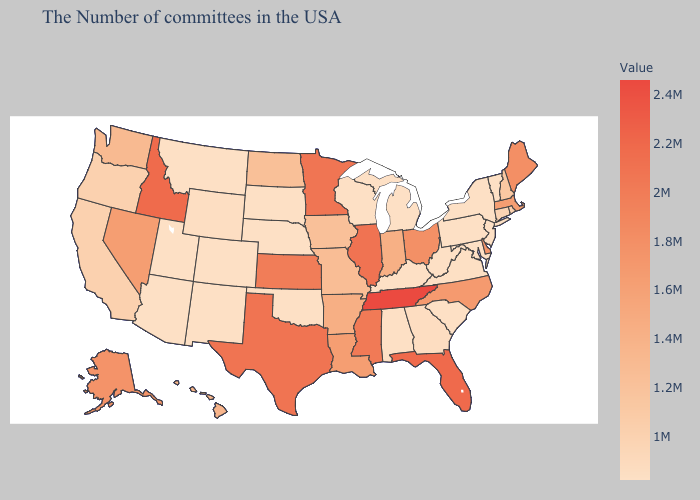Does Pennsylvania have the highest value in the Northeast?
Concise answer only. No. Among the states that border South Dakota , which have the highest value?
Quick response, please. Minnesota. Which states hav the highest value in the South?
Be succinct. Tennessee. Among the states that border Wisconsin , which have the lowest value?
Answer briefly. Michigan. Which states have the lowest value in the West?
Quick response, please. Colorado, New Mexico, Utah, Montana, Arizona. Is the legend a continuous bar?
Quick response, please. Yes. Which states have the lowest value in the USA?
Answer briefly. Vermont, New York, New Jersey, Maryland, Pennsylvania, South Carolina, West Virginia, Michigan, Kentucky, Alabama, Wisconsin, Nebraska, Oklahoma, South Dakota, Colorado, New Mexico, Utah, Montana, Arizona. 